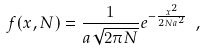Convert formula to latex. <formula><loc_0><loc_0><loc_500><loc_500>f ( x , N ) = \frac { 1 } { a \sqrt { 2 \pi N } } e ^ { - \frac { x ^ { 2 } } { 2 N a ^ { 2 } } } \ ,</formula> 